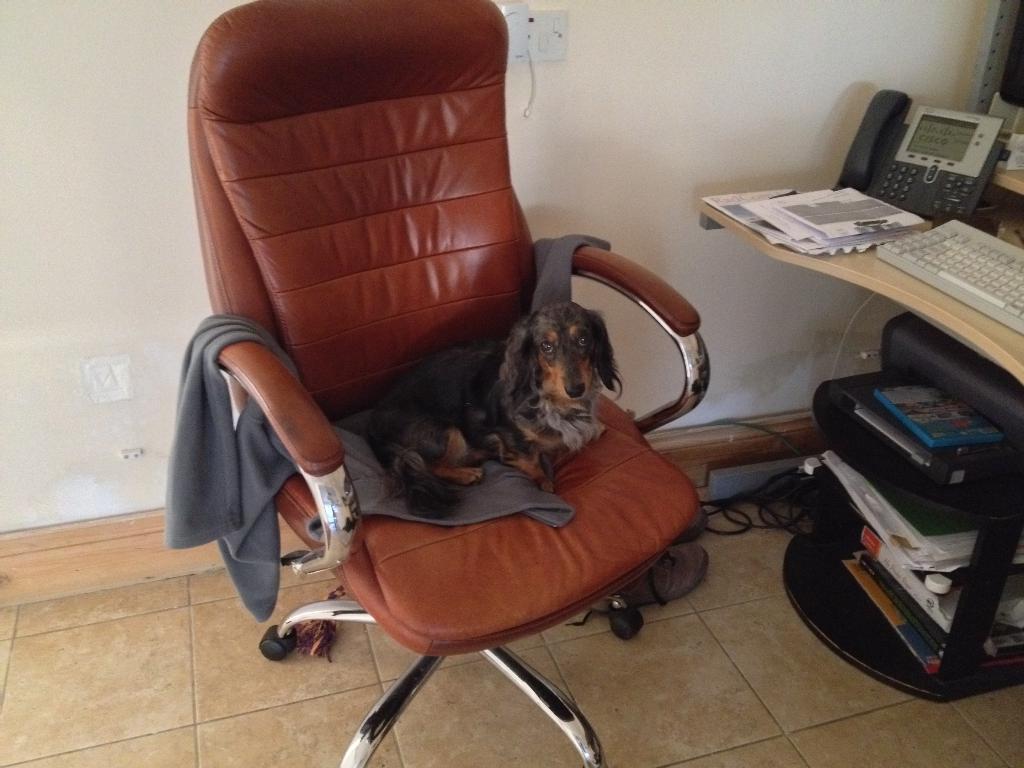How would you summarize this image in a sentence or two? This picture is clicked inside the room. In the center there is a brown colour chair and a dog is sitting on this chair. At the right side on the table there is a fax phone, keyboard, papers. In the background there is a wall socket. At the right side under the table there are files, black colour bag. On the floor there are wires. 